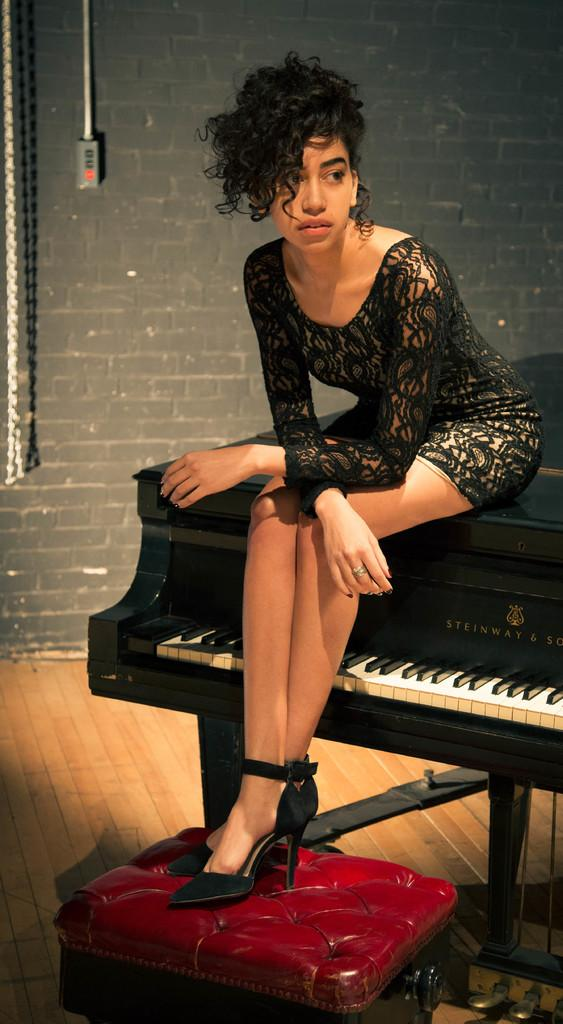Who is the person in the image? There is a woman in the image. What is the woman doing in the image? The woman is sitting on a keyboard. What is the woman wearing in the image? The woman is wearing a black dress. What can be seen in the background of the image? There is a wall in the background of the image. What type of squirrel can be seen climbing the wall in the image? There is no squirrel present in the image; it only features a woman sitting on a keyboard. What discovery was made by the woman in the image? There is no indication of a discovery being made in the image. 